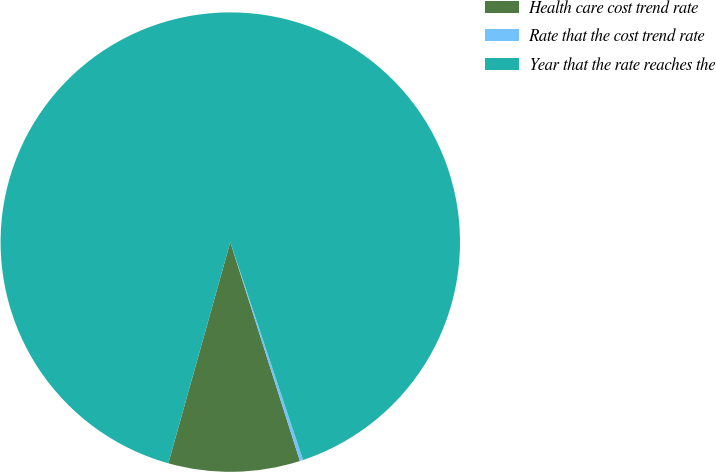Convert chart to OTSL. <chart><loc_0><loc_0><loc_500><loc_500><pie_chart><fcel>Health care cost trend rate<fcel>Rate that the cost trend rate<fcel>Year that the rate reaches the<nl><fcel>9.25%<fcel>0.23%<fcel>90.52%<nl></chart> 